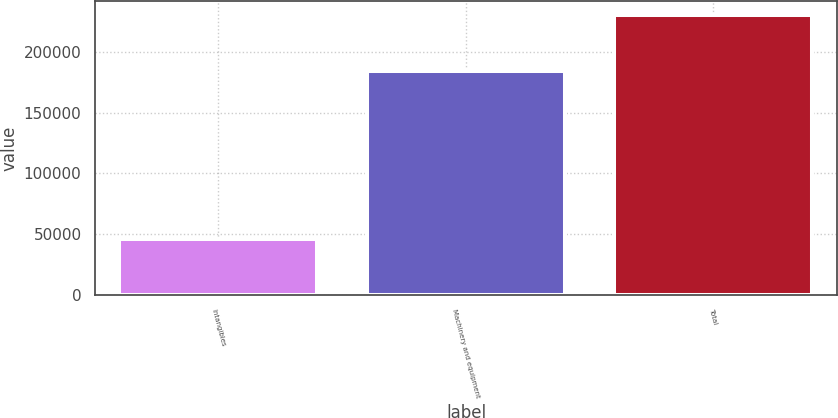Convert chart. <chart><loc_0><loc_0><loc_500><loc_500><bar_chart><fcel>Intangibles<fcel>Machinery and equipment<fcel>Total<nl><fcel>46206<fcel>183906<fcel>230112<nl></chart> 